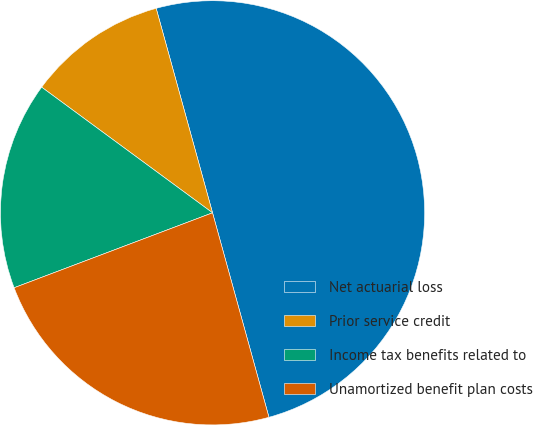<chart> <loc_0><loc_0><loc_500><loc_500><pie_chart><fcel>Net actuarial loss<fcel>Prior service credit<fcel>Income tax benefits related to<fcel>Unamortized benefit plan costs<nl><fcel>50.0%<fcel>10.63%<fcel>15.84%<fcel>23.54%<nl></chart> 